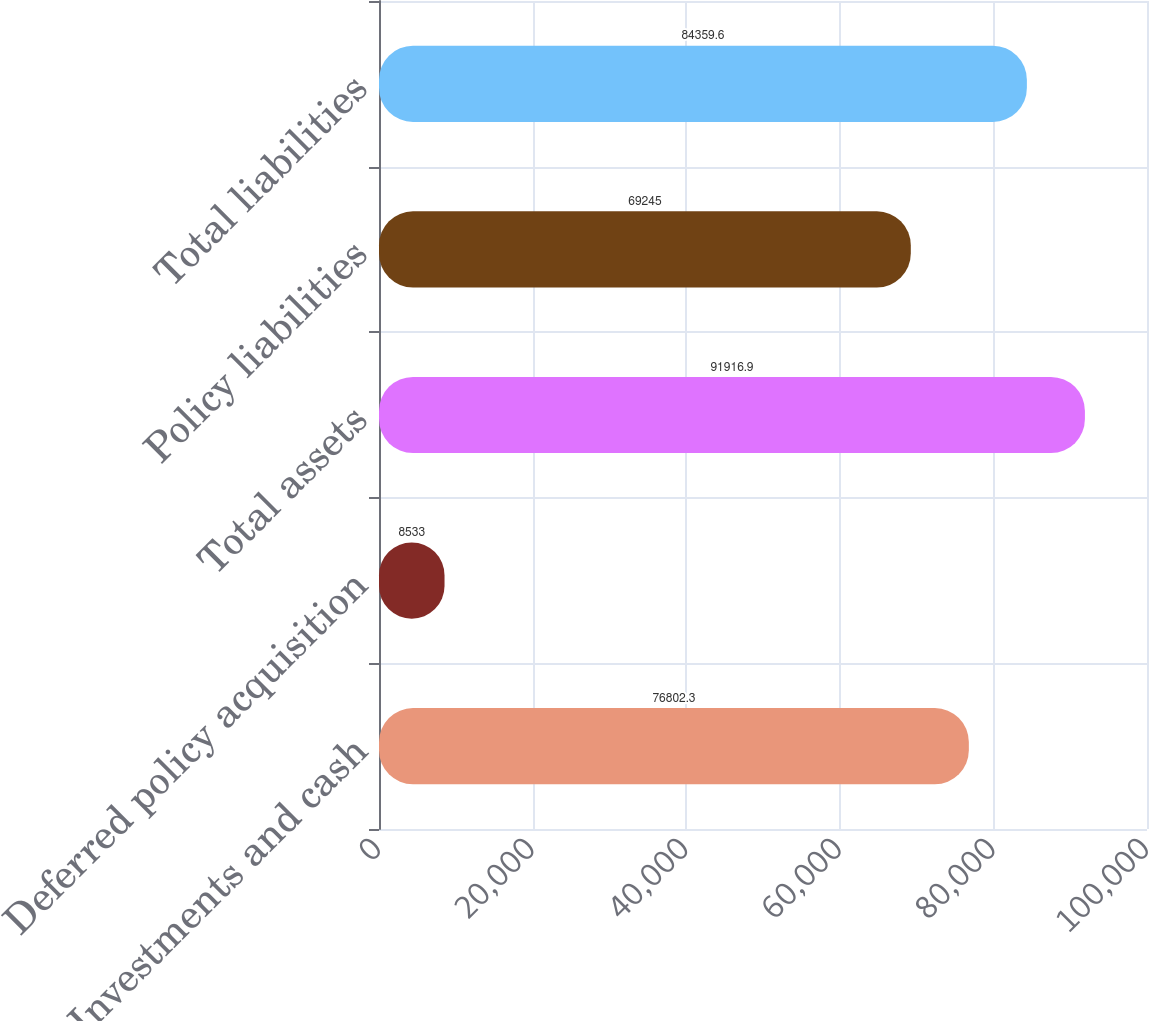Convert chart. <chart><loc_0><loc_0><loc_500><loc_500><bar_chart><fcel>Investments and cash<fcel>Deferred policy acquisition<fcel>Total assets<fcel>Policy liabilities<fcel>Total liabilities<nl><fcel>76802.3<fcel>8533<fcel>91916.9<fcel>69245<fcel>84359.6<nl></chart> 